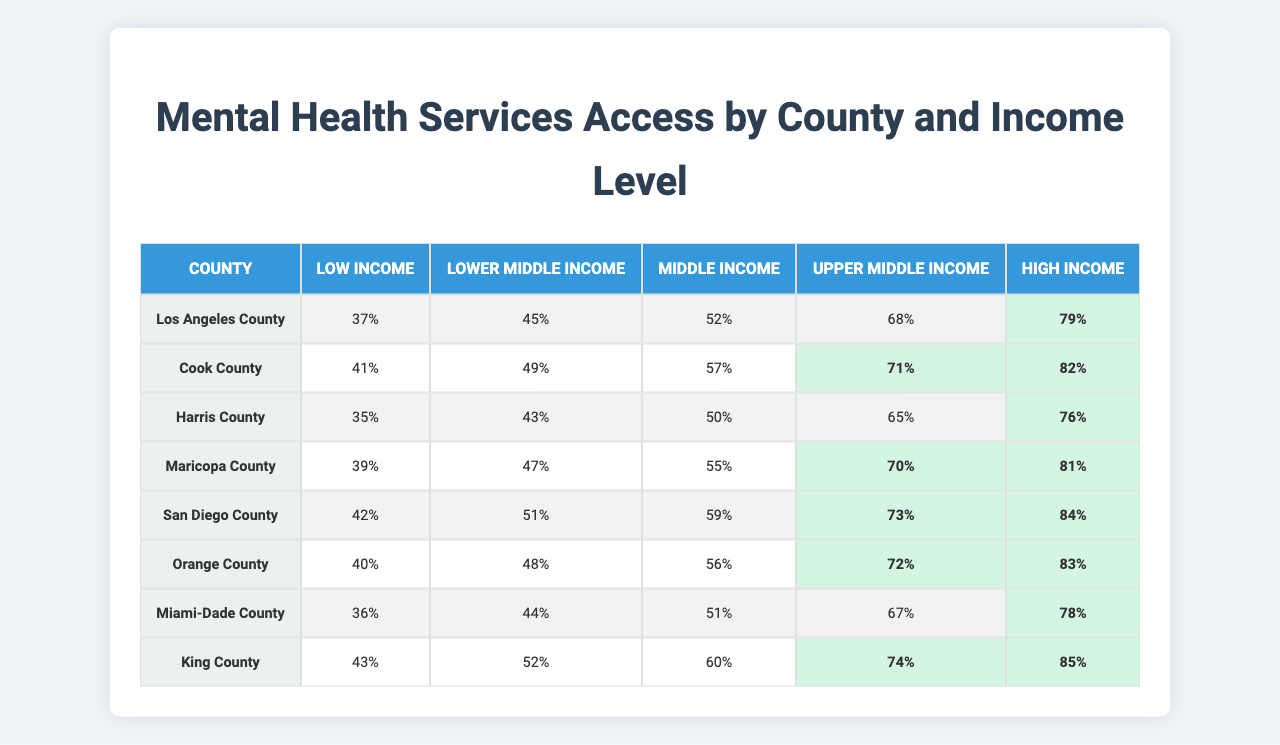What percentage of the population in Los Angeles County has access to mental health services for low-income individuals? The table shows the access percentage for Los Angeles County under the "Low Income" category, which is 37%.
Answer: 37% What is the highest percentage of access to mental health services in San Diego County? The highest percentage in San Diego County is for the "High Income" level, which is 84%.
Answer: 84% In which county do middle-income individuals have the lowest access to mental health services? In the table, Harris County shows the lowest percentage for "Middle Income," which is 50%.
Answer: Harris County What is the average access percentage for "Upper Middle Income" across all counties? To find the average, add the percentages for "Upper Middle Income": 68 + 71 + 65 + 70 + 73 + 72 + 67 + 74 = 500, then divide by 8 counties: 500 / 8 = 62.5%.
Answer: 62.5% Which county ranks highest for "High Income" access, and what is the percentage? The highest percentage for "High Income" is in Orange County at 83%.
Answer: Orange County, 83% Is it true that Cook County has better access for "Lower Middle Income" than it does for "Low Income"? Yes, the table shows that Cook County has 49% for "Lower Middle Income" compared to 41% for "Low Income."
Answer: Yes What is the difference in access percentages for "Lower Middle Income" between Cook County and Harris County? Cook County has 49% and Harris County has 43% for "Lower Middle Income." The difference is 49% - 43% = 6%.
Answer: 6% Which income level has the greatest overall access percentage across all counties? Reviewing the table, the "High Income" level has the highest percentages across all counties, with the lowest being 76% (Harris County) and the highest being 85% (Miami-Dade County).
Answer: High Income What is the percentage of access for middle-income individuals in King County? The table indicates that the access percentage for "Middle Income" in King County is 51%.
Answer: 51% Which income level shows a consistent increase in access percentage as we move from low to high income across all counties? Observing each row, the access percentage consistently increases for all counties from "Low Income" to "High Income."
Answer: Yes 